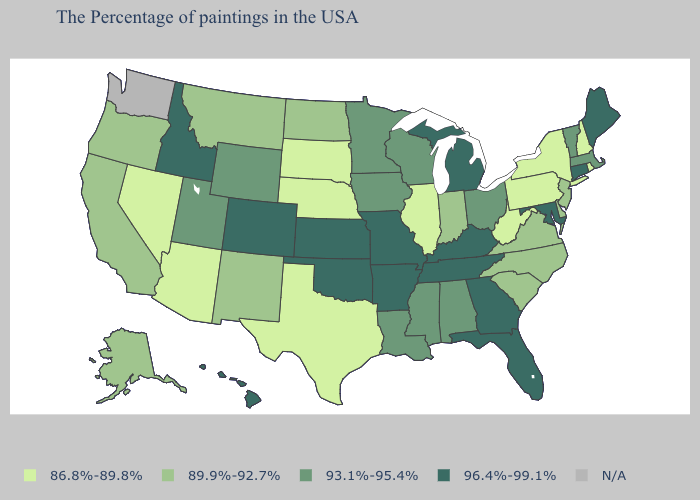Does Nebraska have the highest value in the MidWest?
Quick response, please. No. Name the states that have a value in the range N/A?
Quick response, please. Washington. What is the value of Maryland?
Write a very short answer. 96.4%-99.1%. What is the value of Louisiana?
Be succinct. 93.1%-95.4%. What is the highest value in the USA?
Short answer required. 96.4%-99.1%. What is the value of Delaware?
Keep it brief. 89.9%-92.7%. Name the states that have a value in the range 93.1%-95.4%?
Be succinct. Massachusetts, Vermont, Ohio, Alabama, Wisconsin, Mississippi, Louisiana, Minnesota, Iowa, Wyoming, Utah. Which states have the highest value in the USA?
Quick response, please. Maine, Connecticut, Maryland, Florida, Georgia, Michigan, Kentucky, Tennessee, Missouri, Arkansas, Kansas, Oklahoma, Colorado, Idaho, Hawaii. What is the highest value in states that border Maine?
Keep it brief. 86.8%-89.8%. Among the states that border Connecticut , which have the highest value?
Quick response, please. Massachusetts. Does the map have missing data?
Answer briefly. Yes. Which states have the lowest value in the West?
Keep it brief. Arizona, Nevada. What is the value of Mississippi?
Answer briefly. 93.1%-95.4%. What is the value of West Virginia?
Keep it brief. 86.8%-89.8%. 